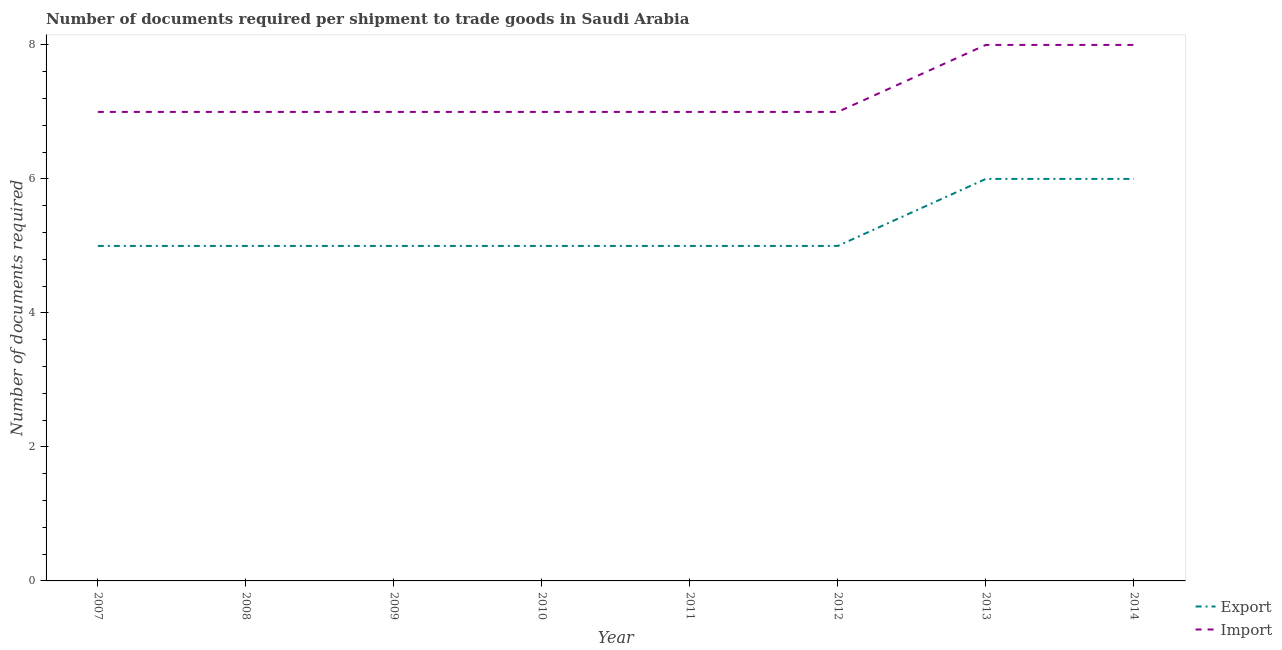How many different coloured lines are there?
Offer a very short reply. 2. What is the number of documents required to import goods in 2010?
Give a very brief answer. 7. Across all years, what is the minimum number of documents required to export goods?
Make the answer very short. 5. In which year was the number of documents required to export goods maximum?
Your answer should be compact. 2013. In which year was the number of documents required to export goods minimum?
Provide a short and direct response. 2007. What is the total number of documents required to import goods in the graph?
Ensure brevity in your answer.  58. What is the difference between the number of documents required to export goods in 2010 and that in 2014?
Your answer should be compact. -1. What is the difference between the number of documents required to import goods in 2013 and the number of documents required to export goods in 2012?
Ensure brevity in your answer.  3. What is the average number of documents required to export goods per year?
Provide a succinct answer. 5.25. In the year 2007, what is the difference between the number of documents required to export goods and number of documents required to import goods?
Give a very brief answer. -2. In how many years, is the number of documents required to export goods greater than 4.4?
Your answer should be compact. 8. What is the ratio of the number of documents required to export goods in 2007 to that in 2012?
Your response must be concise. 1. What is the difference between the highest and the lowest number of documents required to import goods?
Give a very brief answer. 1. What is the difference between two consecutive major ticks on the Y-axis?
Provide a short and direct response. 2. Does the graph contain grids?
Keep it short and to the point. No. What is the title of the graph?
Give a very brief answer. Number of documents required per shipment to trade goods in Saudi Arabia. Does "Birth rate" appear as one of the legend labels in the graph?
Offer a very short reply. No. What is the label or title of the Y-axis?
Provide a short and direct response. Number of documents required. What is the Number of documents required in Import in 2007?
Provide a short and direct response. 7. What is the Number of documents required of Export in 2008?
Your answer should be compact. 5. What is the Number of documents required in Export in 2009?
Make the answer very short. 5. What is the Number of documents required in Import in 2009?
Your response must be concise. 7. What is the Number of documents required of Export in 2010?
Give a very brief answer. 5. What is the Number of documents required in Export in 2012?
Offer a terse response. 5. What is the Number of documents required in Import in 2013?
Your answer should be very brief. 8. What is the Number of documents required in Export in 2014?
Provide a short and direct response. 6. Across all years, what is the maximum Number of documents required of Export?
Keep it short and to the point. 6. Across all years, what is the minimum Number of documents required in Export?
Offer a terse response. 5. Across all years, what is the minimum Number of documents required of Import?
Your answer should be very brief. 7. What is the total Number of documents required in Import in the graph?
Make the answer very short. 58. What is the difference between the Number of documents required of Import in 2007 and that in 2008?
Your response must be concise. 0. What is the difference between the Number of documents required of Import in 2007 and that in 2010?
Offer a very short reply. 0. What is the difference between the Number of documents required in Export in 2007 and that in 2011?
Give a very brief answer. 0. What is the difference between the Number of documents required of Import in 2007 and that in 2011?
Your answer should be compact. 0. What is the difference between the Number of documents required in Import in 2007 and that in 2012?
Give a very brief answer. 0. What is the difference between the Number of documents required of Import in 2008 and that in 2010?
Give a very brief answer. 0. What is the difference between the Number of documents required in Export in 2008 and that in 2012?
Keep it short and to the point. 0. What is the difference between the Number of documents required of Import in 2008 and that in 2012?
Your answer should be compact. 0. What is the difference between the Number of documents required of Import in 2008 and that in 2013?
Provide a short and direct response. -1. What is the difference between the Number of documents required in Export in 2008 and that in 2014?
Ensure brevity in your answer.  -1. What is the difference between the Number of documents required of Export in 2009 and that in 2010?
Make the answer very short. 0. What is the difference between the Number of documents required of Import in 2009 and that in 2010?
Your answer should be compact. 0. What is the difference between the Number of documents required in Export in 2009 and that in 2011?
Keep it short and to the point. 0. What is the difference between the Number of documents required in Import in 2009 and that in 2011?
Provide a short and direct response. 0. What is the difference between the Number of documents required of Export in 2009 and that in 2012?
Provide a short and direct response. 0. What is the difference between the Number of documents required of Import in 2009 and that in 2013?
Provide a short and direct response. -1. What is the difference between the Number of documents required of Import in 2009 and that in 2014?
Offer a terse response. -1. What is the difference between the Number of documents required in Import in 2010 and that in 2011?
Your response must be concise. 0. What is the difference between the Number of documents required in Export in 2010 and that in 2012?
Offer a very short reply. 0. What is the difference between the Number of documents required in Import in 2010 and that in 2012?
Ensure brevity in your answer.  0. What is the difference between the Number of documents required of Import in 2010 and that in 2014?
Your response must be concise. -1. What is the difference between the Number of documents required in Export in 2011 and that in 2013?
Your answer should be very brief. -1. What is the difference between the Number of documents required of Import in 2011 and that in 2013?
Ensure brevity in your answer.  -1. What is the difference between the Number of documents required of Export in 2011 and that in 2014?
Offer a terse response. -1. What is the difference between the Number of documents required in Import in 2011 and that in 2014?
Offer a very short reply. -1. What is the difference between the Number of documents required in Export in 2012 and that in 2013?
Make the answer very short. -1. What is the difference between the Number of documents required in Import in 2012 and that in 2014?
Make the answer very short. -1. What is the difference between the Number of documents required of Export in 2013 and that in 2014?
Your answer should be compact. 0. What is the difference between the Number of documents required of Export in 2007 and the Number of documents required of Import in 2008?
Offer a very short reply. -2. What is the difference between the Number of documents required in Export in 2007 and the Number of documents required in Import in 2009?
Your answer should be very brief. -2. What is the difference between the Number of documents required in Export in 2007 and the Number of documents required in Import in 2012?
Your response must be concise. -2. What is the difference between the Number of documents required of Export in 2008 and the Number of documents required of Import in 2012?
Offer a very short reply. -2. What is the difference between the Number of documents required in Export in 2008 and the Number of documents required in Import in 2014?
Make the answer very short. -3. What is the difference between the Number of documents required of Export in 2009 and the Number of documents required of Import in 2011?
Provide a succinct answer. -2. What is the difference between the Number of documents required of Export in 2009 and the Number of documents required of Import in 2014?
Your response must be concise. -3. What is the difference between the Number of documents required of Export in 2010 and the Number of documents required of Import in 2011?
Keep it short and to the point. -2. What is the difference between the Number of documents required of Export in 2012 and the Number of documents required of Import in 2014?
Ensure brevity in your answer.  -3. What is the difference between the Number of documents required in Export in 2013 and the Number of documents required in Import in 2014?
Give a very brief answer. -2. What is the average Number of documents required in Export per year?
Offer a very short reply. 5.25. What is the average Number of documents required of Import per year?
Give a very brief answer. 7.25. In the year 2007, what is the difference between the Number of documents required in Export and Number of documents required in Import?
Provide a short and direct response. -2. In the year 2008, what is the difference between the Number of documents required of Export and Number of documents required of Import?
Your answer should be compact. -2. In the year 2010, what is the difference between the Number of documents required in Export and Number of documents required in Import?
Give a very brief answer. -2. In the year 2012, what is the difference between the Number of documents required of Export and Number of documents required of Import?
Your answer should be very brief. -2. What is the ratio of the Number of documents required in Import in 2007 to that in 2008?
Offer a very short reply. 1. What is the ratio of the Number of documents required in Export in 2007 to that in 2011?
Ensure brevity in your answer.  1. What is the ratio of the Number of documents required in Export in 2007 to that in 2012?
Offer a terse response. 1. What is the ratio of the Number of documents required in Export in 2008 to that in 2009?
Keep it short and to the point. 1. What is the ratio of the Number of documents required in Export in 2008 to that in 2010?
Your answer should be compact. 1. What is the ratio of the Number of documents required of Import in 2008 to that in 2010?
Make the answer very short. 1. What is the ratio of the Number of documents required of Export in 2008 to that in 2011?
Give a very brief answer. 1. What is the ratio of the Number of documents required of Export in 2008 to that in 2012?
Your answer should be compact. 1. What is the ratio of the Number of documents required in Import in 2008 to that in 2012?
Offer a terse response. 1. What is the ratio of the Number of documents required of Import in 2008 to that in 2014?
Offer a terse response. 0.88. What is the ratio of the Number of documents required in Export in 2009 to that in 2010?
Your answer should be compact. 1. What is the ratio of the Number of documents required in Import in 2009 to that in 2010?
Provide a short and direct response. 1. What is the ratio of the Number of documents required of Export in 2009 to that in 2012?
Provide a short and direct response. 1. What is the ratio of the Number of documents required of Import in 2009 to that in 2012?
Ensure brevity in your answer.  1. What is the ratio of the Number of documents required in Export in 2009 to that in 2014?
Give a very brief answer. 0.83. What is the ratio of the Number of documents required of Export in 2010 to that in 2013?
Your answer should be compact. 0.83. What is the ratio of the Number of documents required in Import in 2010 to that in 2014?
Give a very brief answer. 0.88. What is the ratio of the Number of documents required in Export in 2011 to that in 2012?
Offer a terse response. 1. What is the ratio of the Number of documents required in Import in 2011 to that in 2012?
Keep it short and to the point. 1. What is the ratio of the Number of documents required in Import in 2011 to that in 2013?
Ensure brevity in your answer.  0.88. What is the ratio of the Number of documents required of Export in 2012 to that in 2013?
Ensure brevity in your answer.  0.83. What is the ratio of the Number of documents required in Import in 2012 to that in 2013?
Keep it short and to the point. 0.88. What is the ratio of the Number of documents required in Import in 2012 to that in 2014?
Your answer should be compact. 0.88. What is the ratio of the Number of documents required in Export in 2013 to that in 2014?
Keep it short and to the point. 1. What is the ratio of the Number of documents required of Import in 2013 to that in 2014?
Give a very brief answer. 1. What is the difference between the highest and the second highest Number of documents required in Import?
Offer a very short reply. 0. What is the difference between the highest and the lowest Number of documents required of Import?
Make the answer very short. 1. 